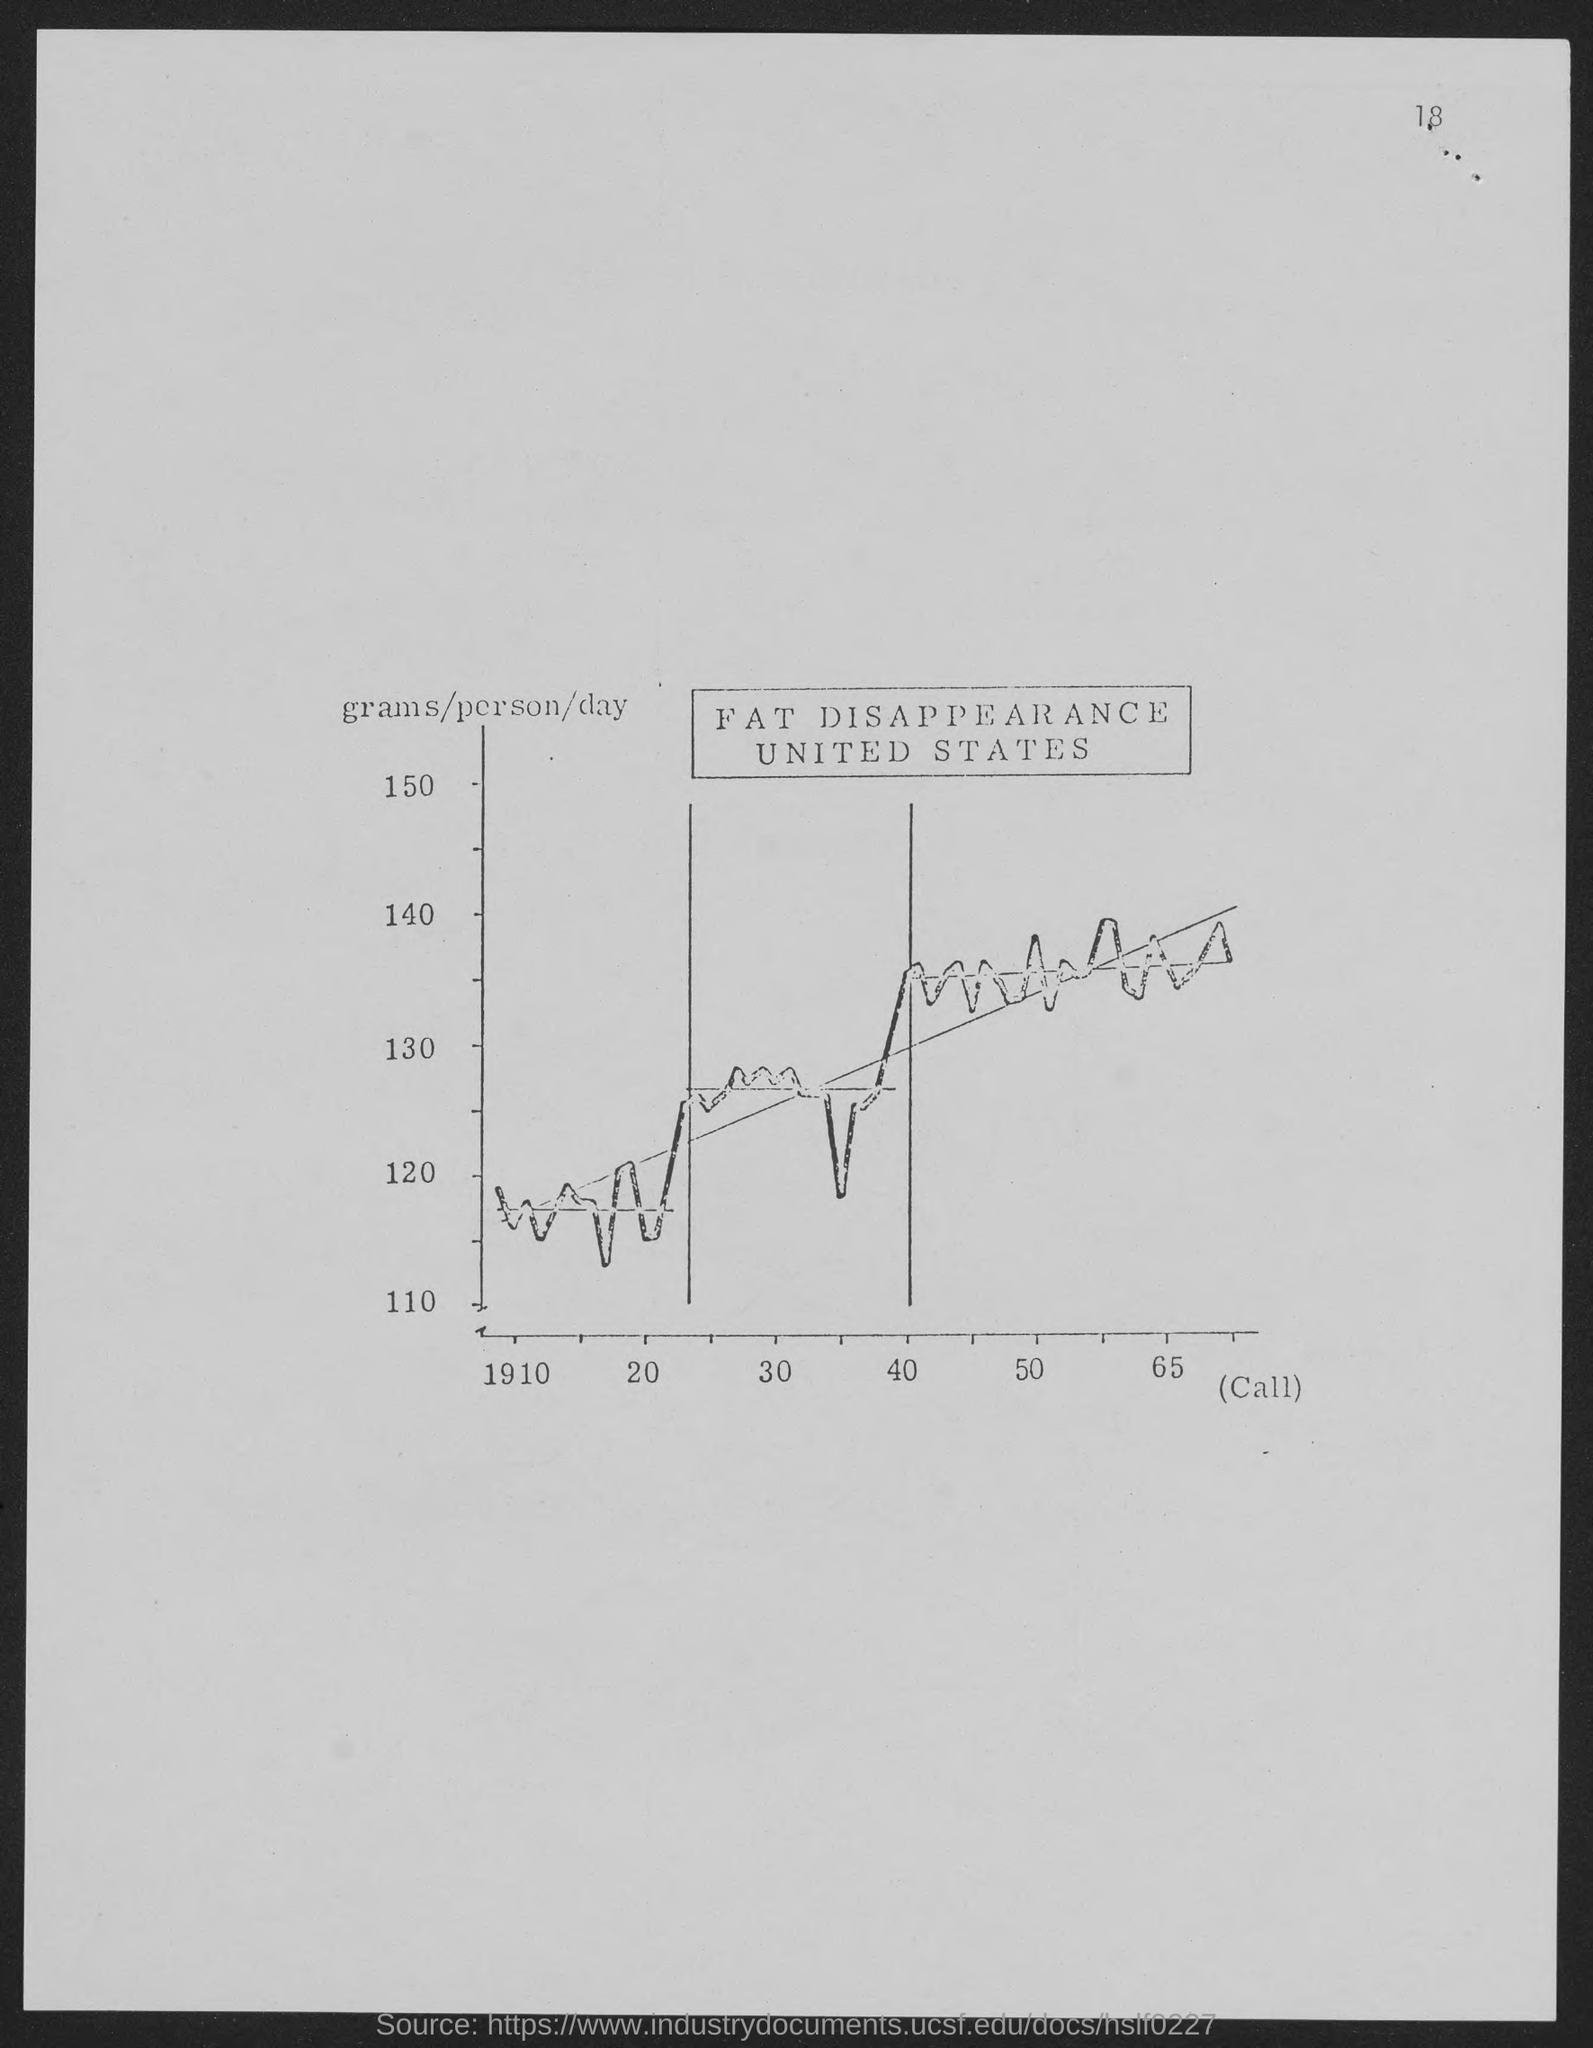What is the number at top-right corner of the page?
Give a very brief answer. 18. 